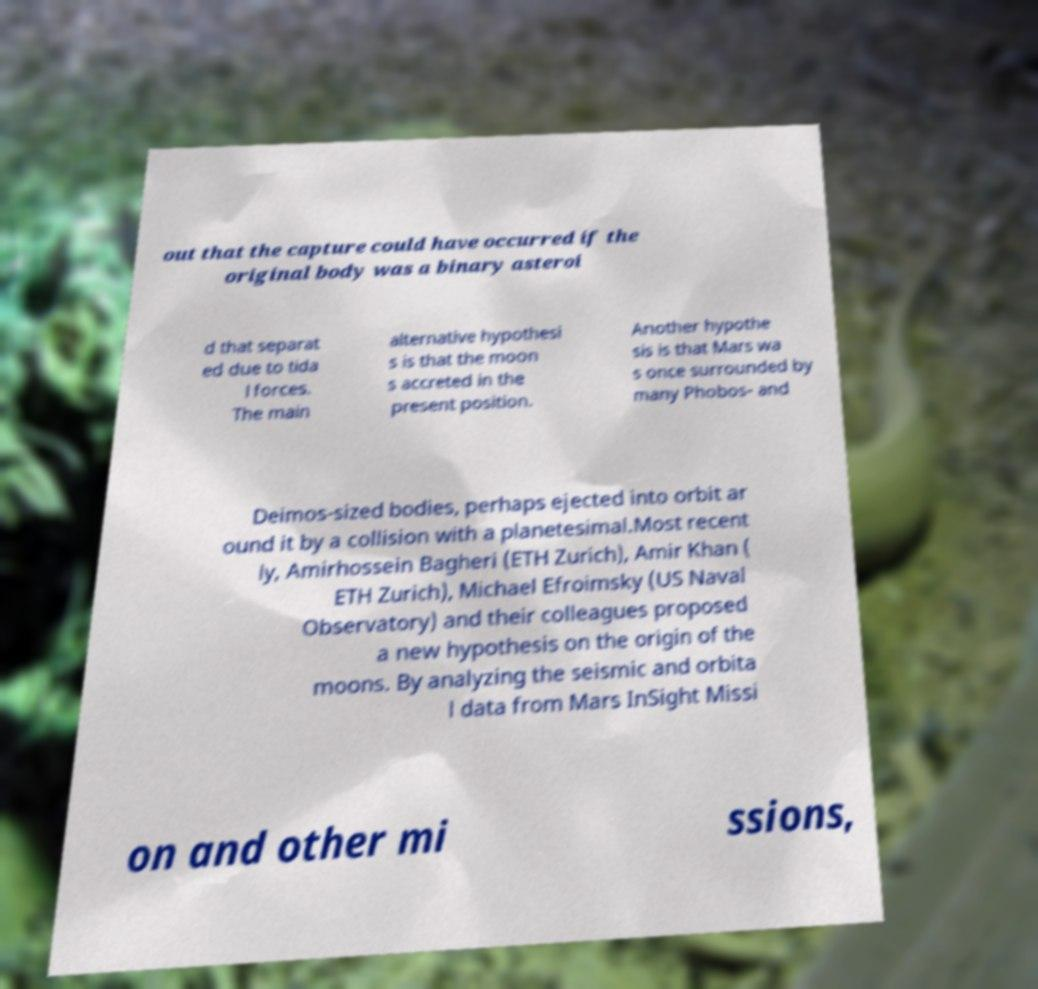Please identify and transcribe the text found in this image. out that the capture could have occurred if the original body was a binary asteroi d that separat ed due to tida l forces. The main alternative hypothesi s is that the moon s accreted in the present position. Another hypothe sis is that Mars wa s once surrounded by many Phobos- and Deimos-sized bodies, perhaps ejected into orbit ar ound it by a collision with a planetesimal.Most recent ly, Amirhossein Bagheri (ETH Zurich), Amir Khan ( ETH Zurich), Michael Efroimsky (US Naval Observatory) and their colleagues proposed a new hypothesis on the origin of the moons. By analyzing the seismic and orbita l data from Mars InSight Missi on and other mi ssions, 